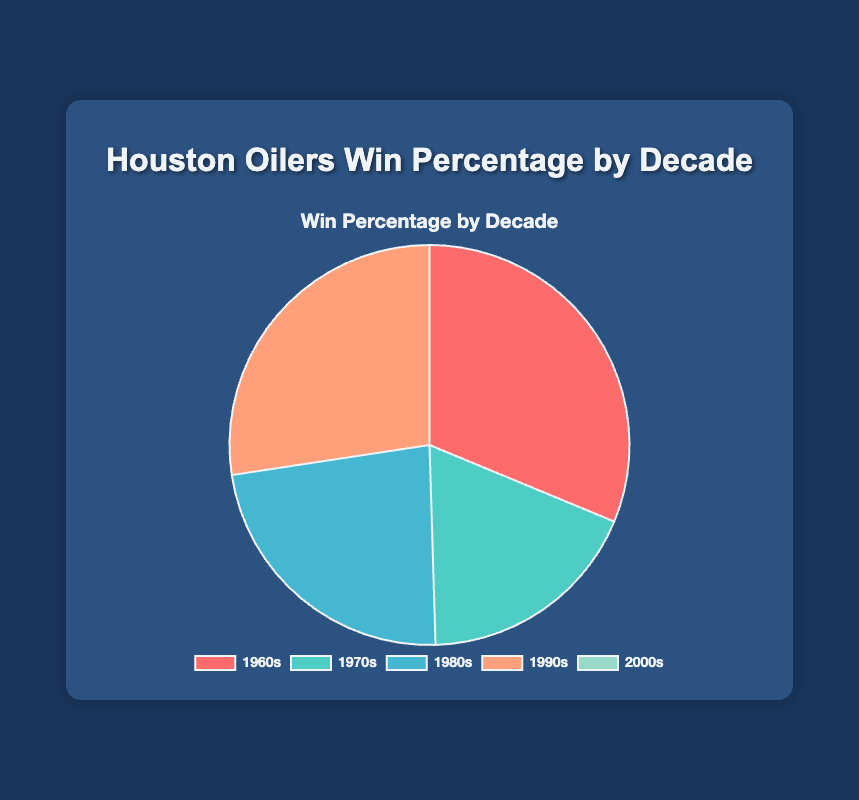Which decade had the highest win percentage? The 1960s segment in the pie chart is the largest, indicating the highest win percentage.
Answer: 1960s Which decade had the lowest win percentage? The 2000s segment is the smallest or non-existent in the pie chart, indicating the lowest win percentage.
Answer: 2000s How did the win percentage change from the 1970s to the 1980s? The 1980s segment is visually larger than the 1970s segment. 38% in the 1970s to 48% in the 1980s shows an increase.
Answer: Increased What is the sum of the win percentages for the 1970s and 1990s? Add the percentages of the 1970s (38%) and the 1990s (57%). 38 + 57 = 95
Answer: 95 What is the difference in win percentage between the 1960s and the 1990s? Subtract the percentage of the 1990s (57%) from the 1960s (65%). 65 - 57 = 8
Answer: 8 Which decade experienced a decline in win percentage compared to the previous decade? Visual inspection shows that the percentage in the 1970s (38%) is less than in the 1960s (65%), indicating a decline.
Answer: 1970s What is the average win percentage across all decades (excluding the 2000s)? Sum the percentages of the 1960s (65%), 1970s (38%), 1980s (48%), and 1990s (57%) and divide by 4. (65 + 38 + 48 + 57) / 4 = 52
Answer: 52 Which segment is colored red and what is its win percentage? The 1960s segment is visually colored red and represents a 65% win percentage.
Answer: 1960s, 65% If you combine the win percentages of the 1960s and 1990s, what proportion of the chart does it represent? Adding the percentages of the 1960s (65%) and the 1990s (57%) gives 122%. Since the total must be 100%, it means: (65% + 57%) / 100% = 122% / 100% = 1.22 or 122% as a total proportion.
Answer: 122% Compared to the 1980s, how much higher was the win percentage in the 1960s? Subtract the win percentage of the 1980s (48%) from the 1960s (65%). 65 - 48 = 17
Answer: 17 